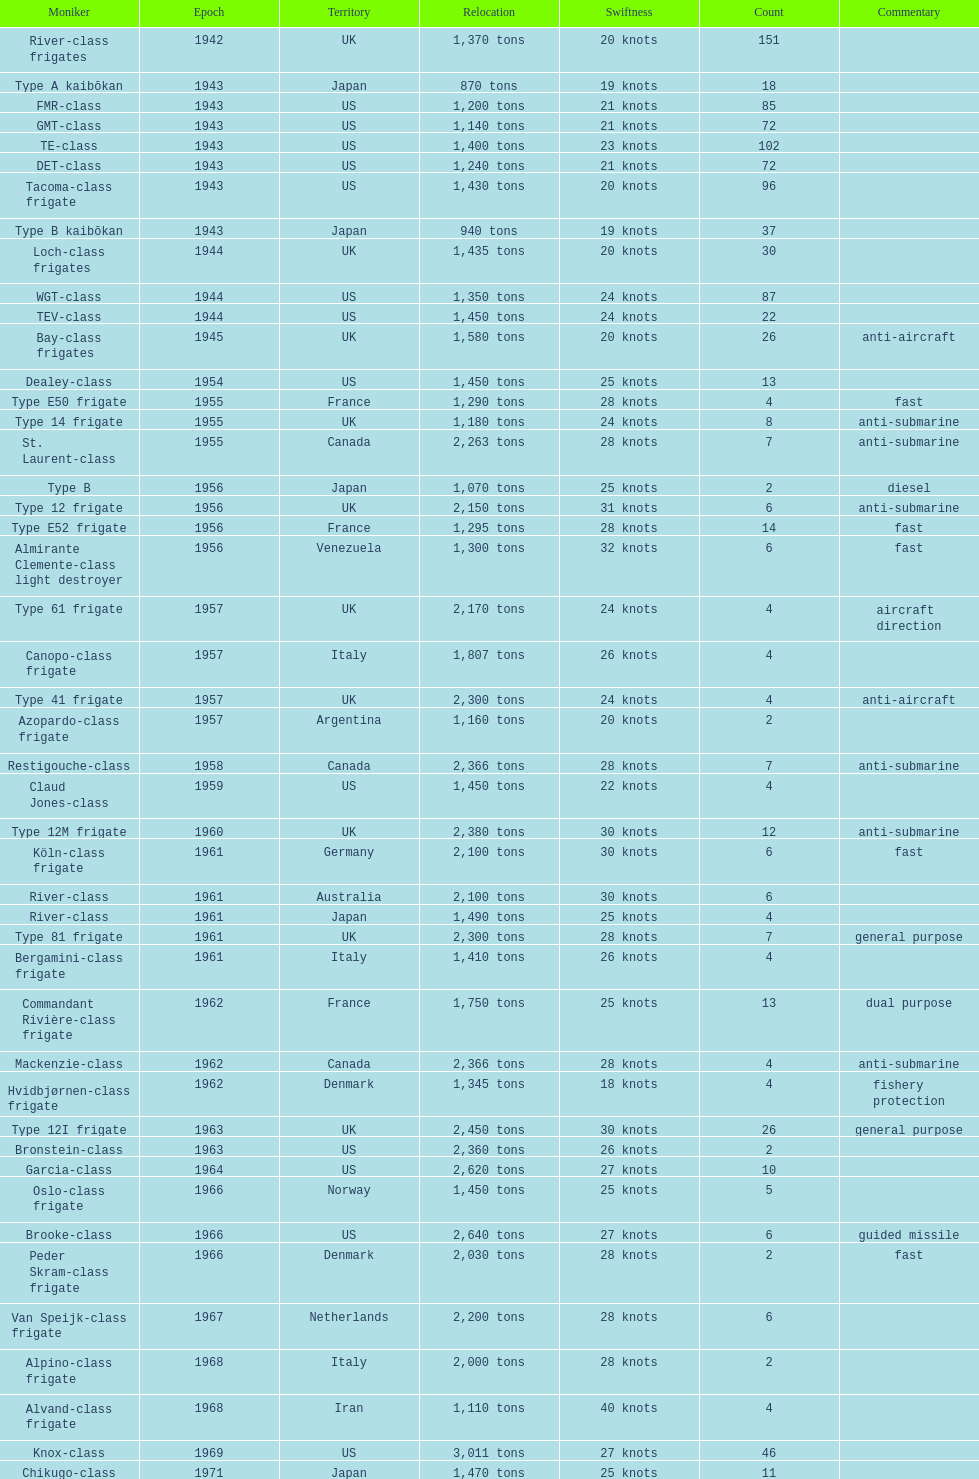Which of the boats listed is the fastest? Alvand-class frigate. 